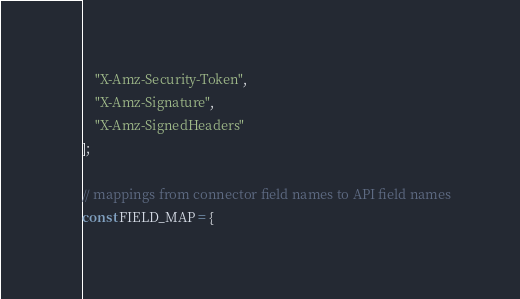Convert code to text. <code><loc_0><loc_0><loc_500><loc_500><_JavaScript_>    "X-Amz-Security-Token",
    "X-Amz-Signature",
    "X-Amz-SignedHeaders"
];

// mappings from connector field names to API field names
const FIELD_MAP = {</code> 